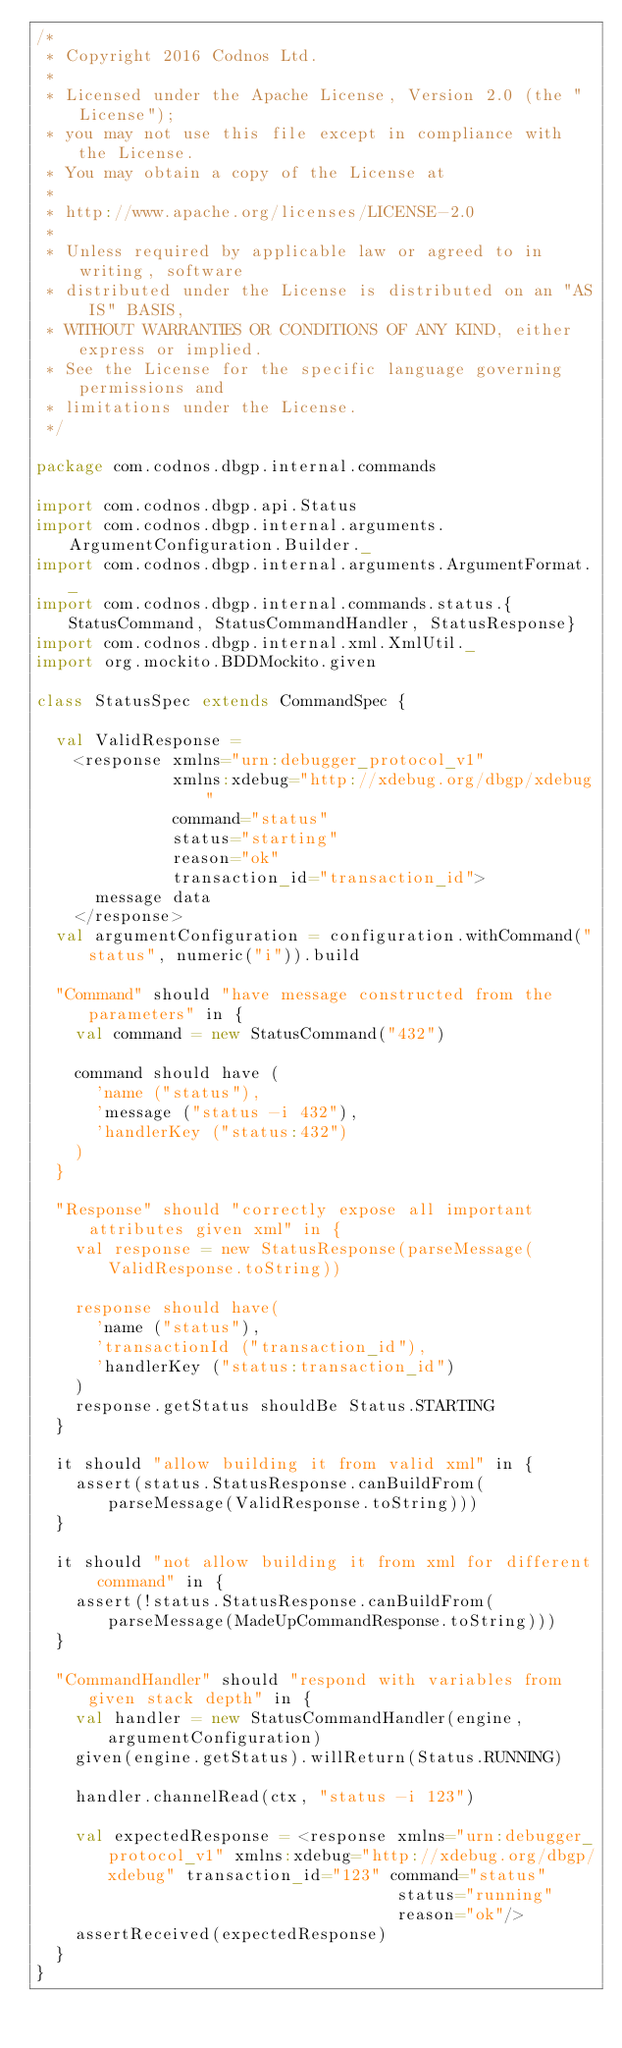Convert code to text. <code><loc_0><loc_0><loc_500><loc_500><_Scala_>/*
 * Copyright 2016 Codnos Ltd.
 *
 * Licensed under the Apache License, Version 2.0 (the "License");
 * you may not use this file except in compliance with the License.
 * You may obtain a copy of the License at
 *
 * http://www.apache.org/licenses/LICENSE-2.0
 *
 * Unless required by applicable law or agreed to in writing, software
 * distributed under the License is distributed on an "AS IS" BASIS,
 * WITHOUT WARRANTIES OR CONDITIONS OF ANY KIND, either express or implied.
 * See the License for the specific language governing permissions and
 * limitations under the License.
 */

package com.codnos.dbgp.internal.commands

import com.codnos.dbgp.api.Status
import com.codnos.dbgp.internal.arguments.ArgumentConfiguration.Builder._
import com.codnos.dbgp.internal.arguments.ArgumentFormat._
import com.codnos.dbgp.internal.commands.status.{StatusCommand, StatusCommandHandler, StatusResponse}
import com.codnos.dbgp.internal.xml.XmlUtil._
import org.mockito.BDDMockito.given

class StatusSpec extends CommandSpec {

  val ValidResponse =
    <response xmlns="urn:debugger_protocol_v1"
              xmlns:xdebug="http://xdebug.org/dbgp/xdebug"
              command="status"
              status="starting"
              reason="ok"
              transaction_id="transaction_id">
      message data
    </response>
  val argumentConfiguration = configuration.withCommand("status", numeric("i")).build

  "Command" should "have message constructed from the parameters" in {
    val command = new StatusCommand("432")

    command should have (
      'name ("status"),
      'message ("status -i 432"),
      'handlerKey ("status:432")
    )
  }

  "Response" should "correctly expose all important attributes given xml" in {
    val response = new StatusResponse(parseMessage(ValidResponse.toString))

    response should have(
      'name ("status"),
      'transactionId ("transaction_id"),
      'handlerKey ("status:transaction_id")
    )
    response.getStatus shouldBe Status.STARTING
  }

  it should "allow building it from valid xml" in {
    assert(status.StatusResponse.canBuildFrom(parseMessage(ValidResponse.toString)))
  }

  it should "not allow building it from xml for different command" in {
    assert(!status.StatusResponse.canBuildFrom(parseMessage(MadeUpCommandResponse.toString)))
  }

  "CommandHandler" should "respond with variables from given stack depth" in {
    val handler = new StatusCommandHandler(engine, argumentConfiguration)
    given(engine.getStatus).willReturn(Status.RUNNING)

    handler.channelRead(ctx, "status -i 123")

    val expectedResponse = <response xmlns="urn:debugger_protocol_v1" xmlns:xdebug="http://xdebug.org/dbgp/xdebug" transaction_id="123" command="status"
                                     status="running"
                                     reason="ok"/>
    assertReceived(expectedResponse)
  }
}
</code> 